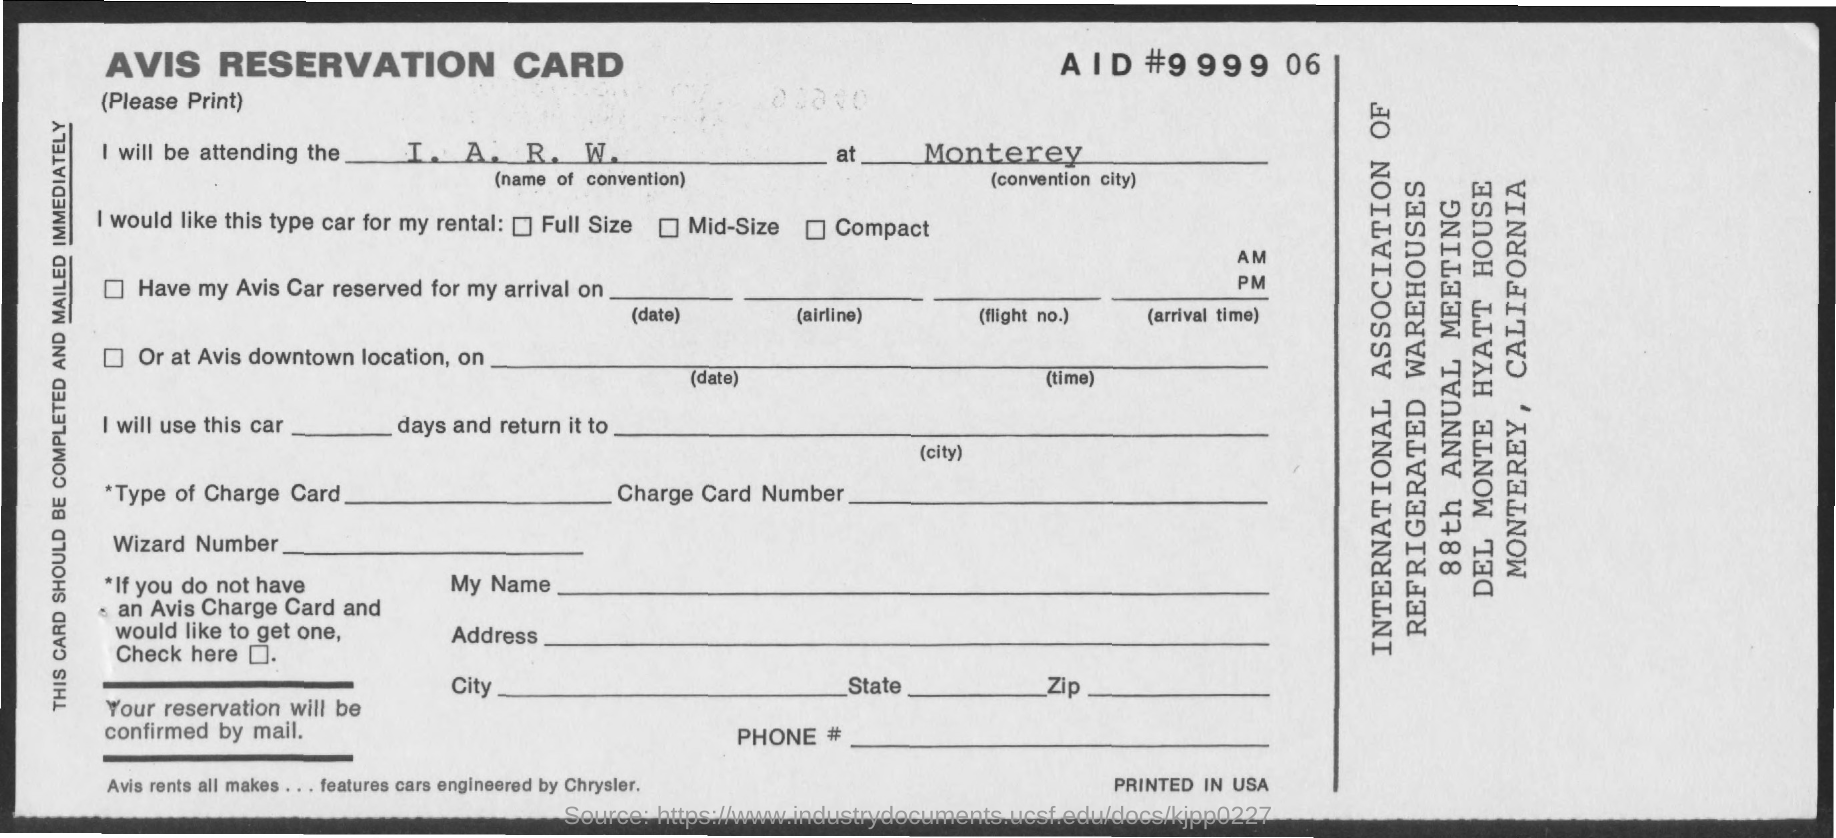Indicate a few pertinent items in this graphic. The city mentioned in the conversation is Monterey. The convention mentioned is called "A. R. W.... 